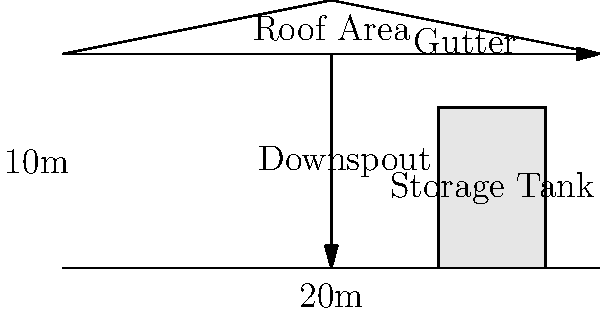As an educator supporting outdoor learning initiatives, you're tasked with designing a rainwater harvesting system for an outdoor education center. The center has a rectangular roof with dimensions of 20m x 10m. If the average annual rainfall in the area is 800mm and the system efficiency is 80%, what is the potential annual rainwater harvest in cubic meters? To calculate the potential annual rainwater harvest, we'll follow these steps:

1. Calculate the roof area:
   $A = 20\text{m} \times 10\text{m} = 200\text{m}^2$

2. Convert the annual rainfall from mm to m:
   $800\text{mm} = 0.8\text{m}$

3. Calculate the total water falling on the roof annually:
   $V_{total} = A \times \text{rainfall}$
   $V_{total} = 200\text{m}^2 \times 0.8\text{m} = 160\text{m}^3$

4. Apply the system efficiency:
   $V_{harvested} = V_{total} \times \text{efficiency}$
   $V_{harvested} = 160\text{m}^3 \times 0.8 = 128\text{m}^3$

Therefore, the potential annual rainwater harvest is 128 cubic meters.
Answer: 128 m³ 